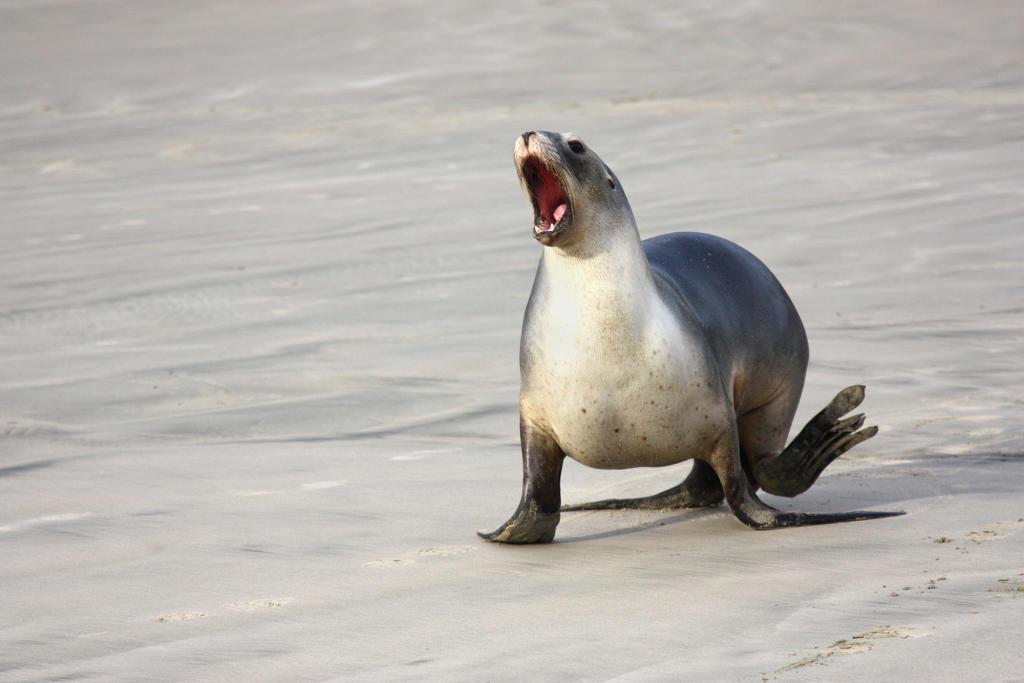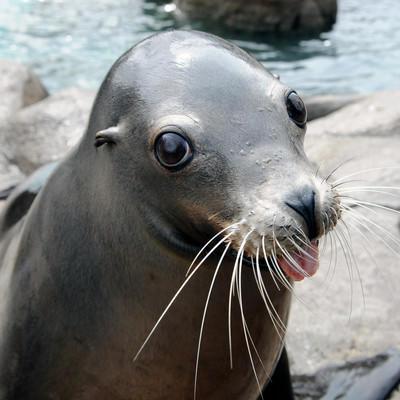The first image is the image on the left, the second image is the image on the right. For the images displayed, is the sentence "There is water in the image on the left." factually correct? Answer yes or no. No. 